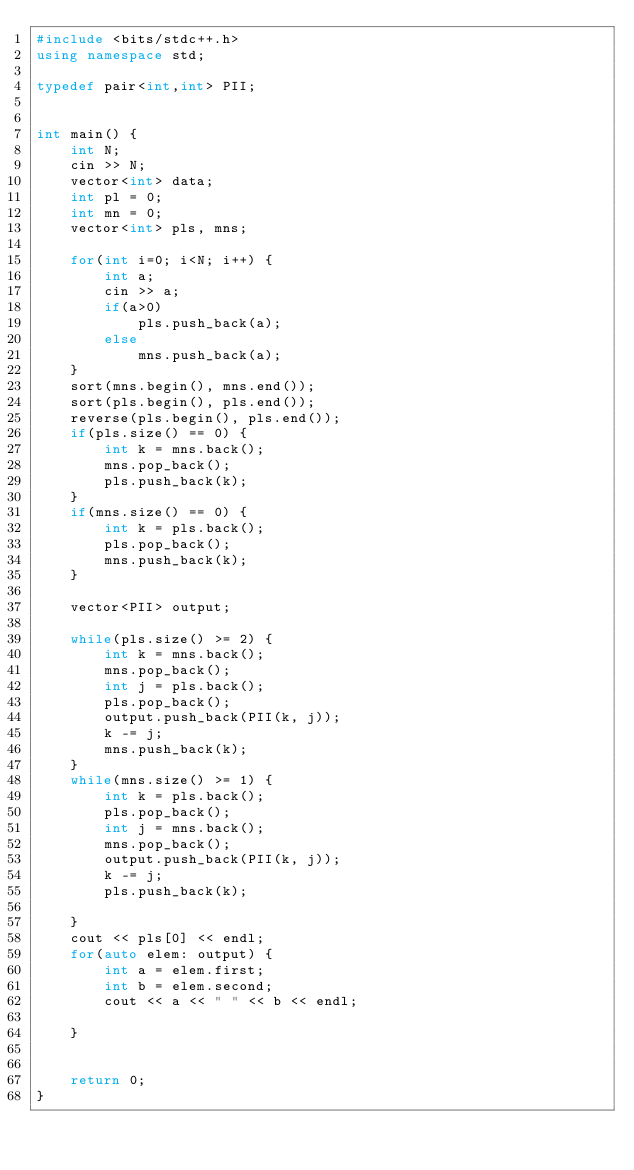<code> <loc_0><loc_0><loc_500><loc_500><_C++_>#include <bits/stdc++.h>
using namespace std;

typedef pair<int,int> PII;


int main() {
    int N;
    cin >> N;
    vector<int> data;
    int pl = 0;
    int mn = 0;
    vector<int> pls, mns;

    for(int i=0; i<N; i++) {
        int a;
        cin >> a;
        if(a>0)
            pls.push_back(a);
        else
            mns.push_back(a);
    }
    sort(mns.begin(), mns.end());
    sort(pls.begin(), pls.end());
    reverse(pls.begin(), pls.end());
    if(pls.size() == 0) {
        int k = mns.back();
        mns.pop_back();
        pls.push_back(k);
    }
    if(mns.size() == 0) {
        int k = pls.back();
        pls.pop_back();
        mns.push_back(k);
    }

    vector<PII> output;

    while(pls.size() >= 2) {
        int k = mns.back();
        mns.pop_back();
        int j = pls.back();
        pls.pop_back();
        output.push_back(PII(k, j));
        k -= j;
        mns.push_back(k);
    }
    while(mns.size() >= 1) {
        int k = pls.back();
        pls.pop_back();
        int j = mns.back();
        mns.pop_back();
        output.push_back(PII(k, j));
        k -= j;
        pls.push_back(k);

    }
    cout << pls[0] << endl;
    for(auto elem: output) {
        int a = elem.first;
        int b = elem.second;
        cout << a << " " << b << endl;
 
    }


    return 0;
} </code> 